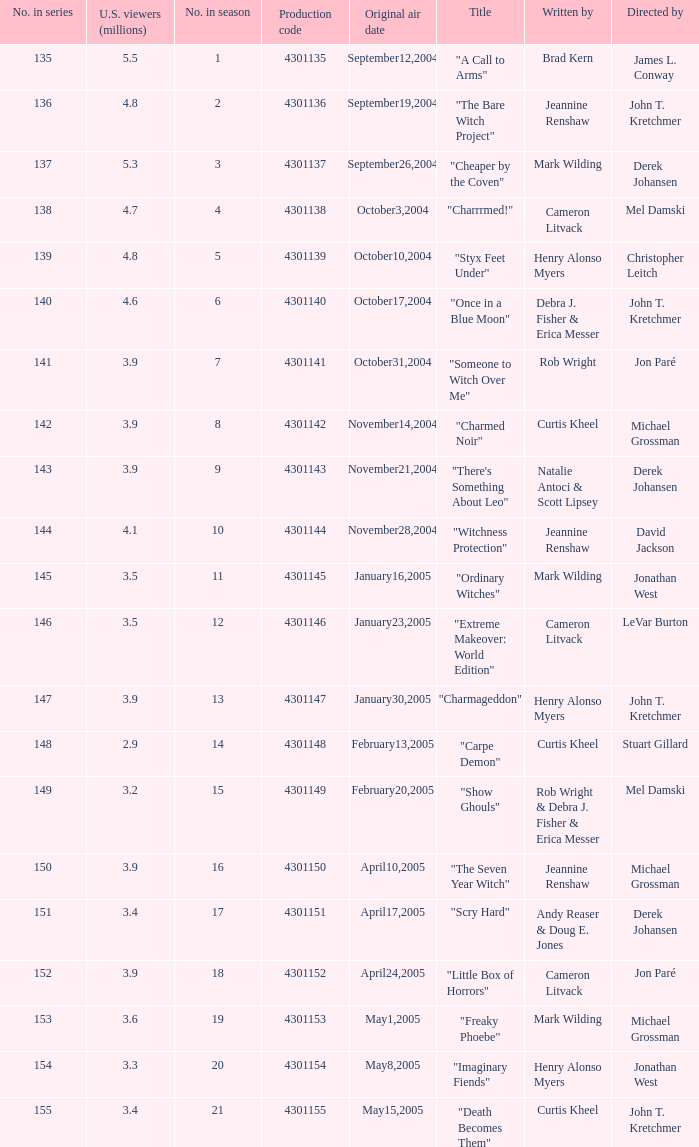In season number 3,  who were the writers? Mark Wilding. 